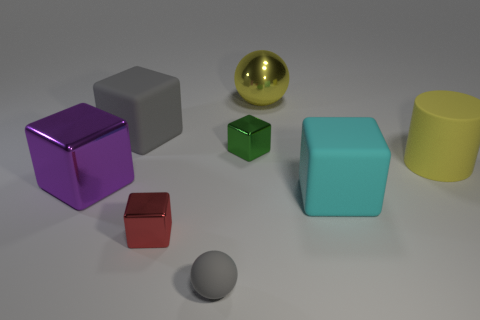Subtract all metal cubes. How many cubes are left? 2 Add 1 gray matte spheres. How many objects exist? 9 Subtract all yellow balls. How many balls are left? 1 Subtract 0 red cylinders. How many objects are left? 8 Subtract all cylinders. How many objects are left? 7 Subtract 1 cylinders. How many cylinders are left? 0 Subtract all red balls. Subtract all red cylinders. How many balls are left? 2 Subtract all purple cylinders. How many cyan balls are left? 0 Subtract all cyan blocks. Subtract all big cyan cubes. How many objects are left? 6 Add 3 metal objects. How many metal objects are left? 7 